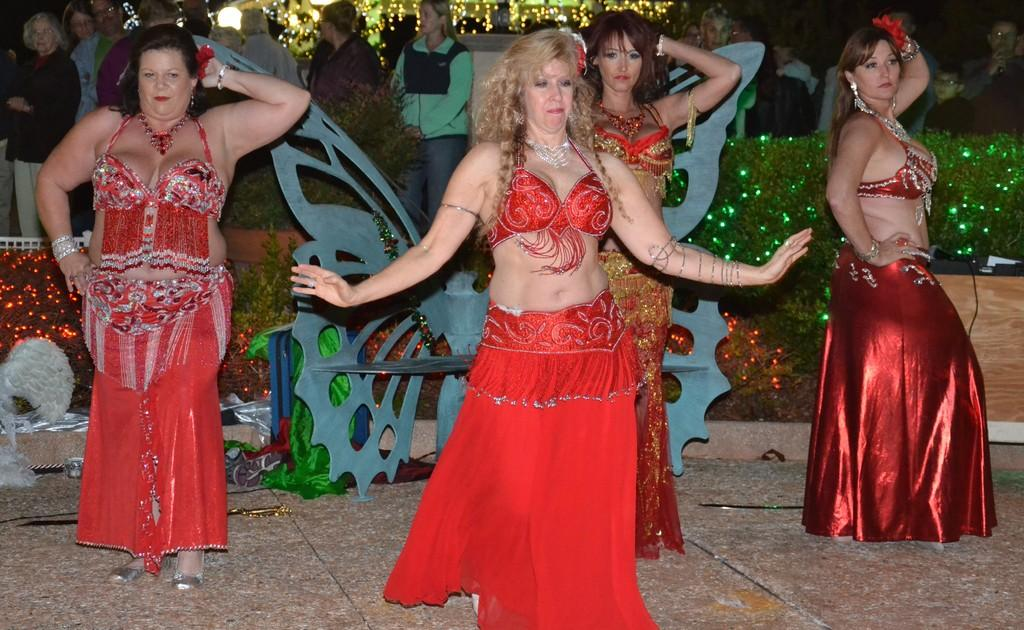How many women are in the image? There are four women in the image. What are the women doing in the image? The women are dancing on the floor. What can be seen in the background of the image? There are plants, decorative objects, and people in the background of the image. Can you describe the lighting in the background of the image? The background view is dark. Can you see the moon and ocean in the background of the image? No, the moon and ocean are not visible in the image. Is there a turkey present in the image? No, there is no turkey present in the image. 